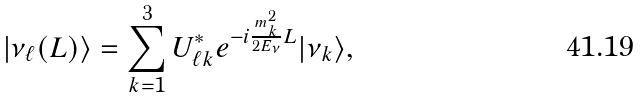Convert formula to latex. <formula><loc_0><loc_0><loc_500><loc_500>| \nu _ { \ell } ( L ) \rangle = \sum _ { k = 1 } ^ { 3 } U ^ { * } _ { \ell k } e ^ { - i \frac { m _ { k } ^ { 2 } } { 2 E _ { \nu } } L } | \nu _ { k } \rangle ,</formula> 